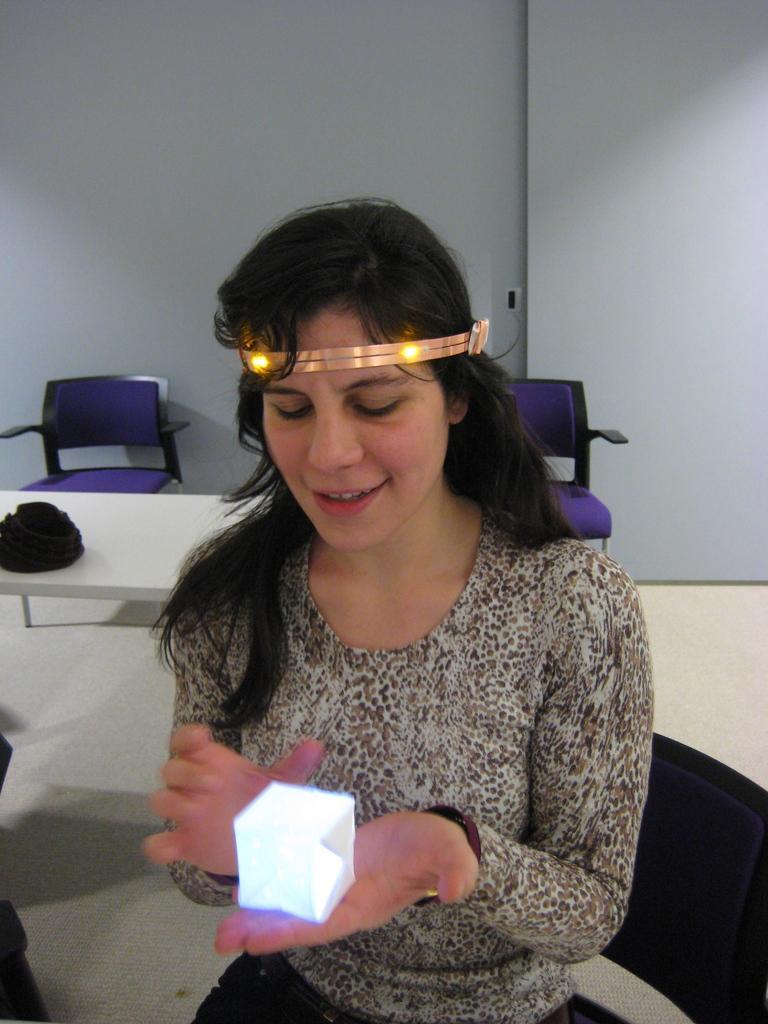How would you summarize this image in a sentence or two? A woman is holding an object, these are chairs. 